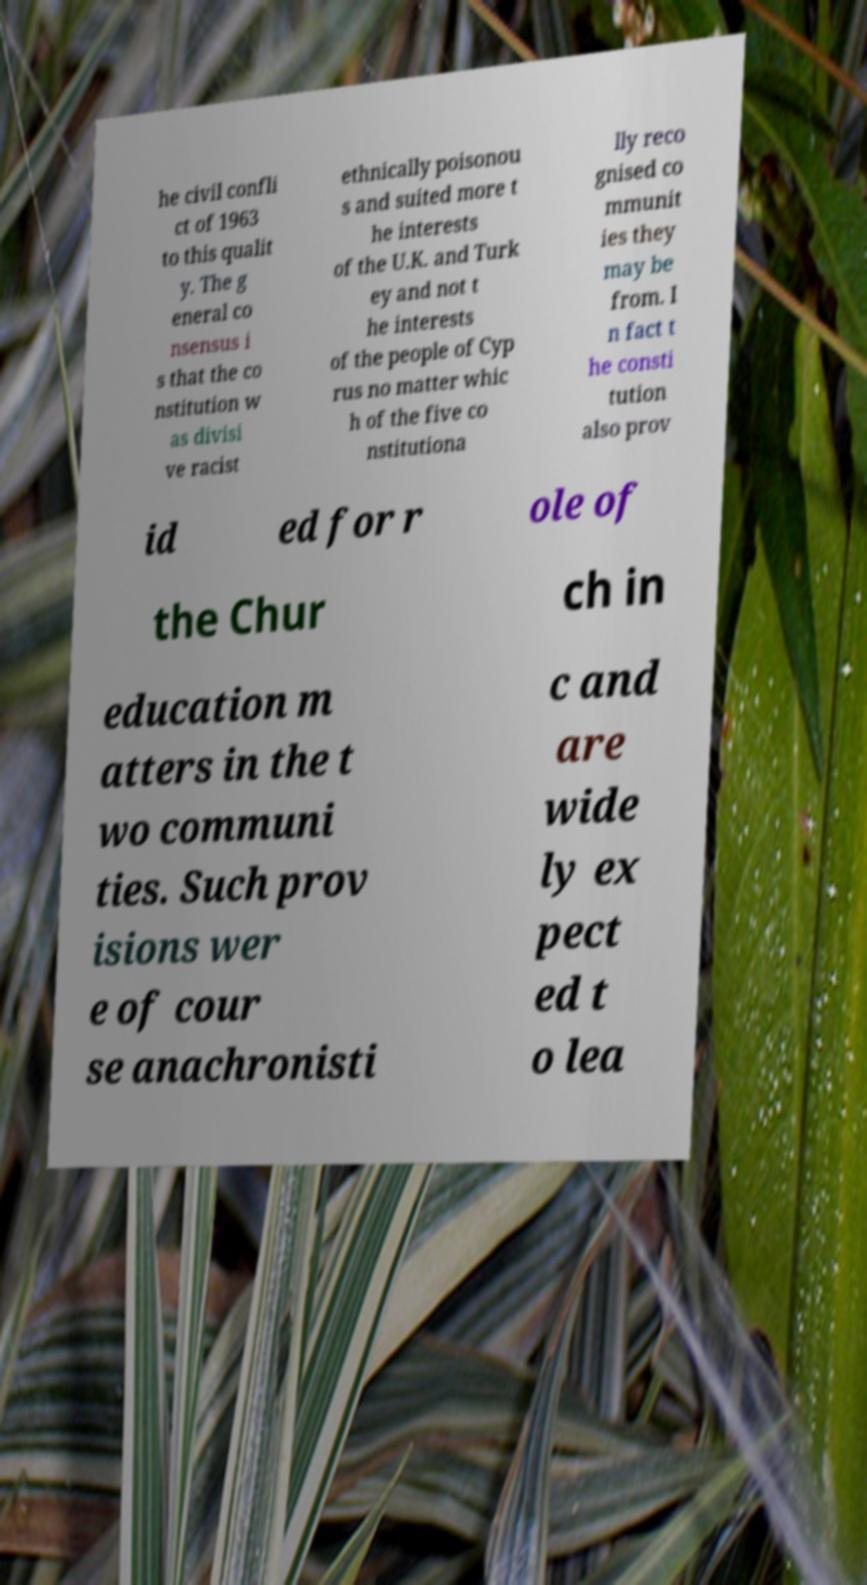Can you read and provide the text displayed in the image?This photo seems to have some interesting text. Can you extract and type it out for me? he civil confli ct of 1963 to this qualit y. The g eneral co nsensus i s that the co nstitution w as divisi ve racist ethnically poisonou s and suited more t he interests of the U.K. and Turk ey and not t he interests of the people of Cyp rus no matter whic h of the five co nstitutiona lly reco gnised co mmunit ies they may be from. I n fact t he consti tution also prov id ed for r ole of the Chur ch in education m atters in the t wo communi ties. Such prov isions wer e of cour se anachronisti c and are wide ly ex pect ed t o lea 